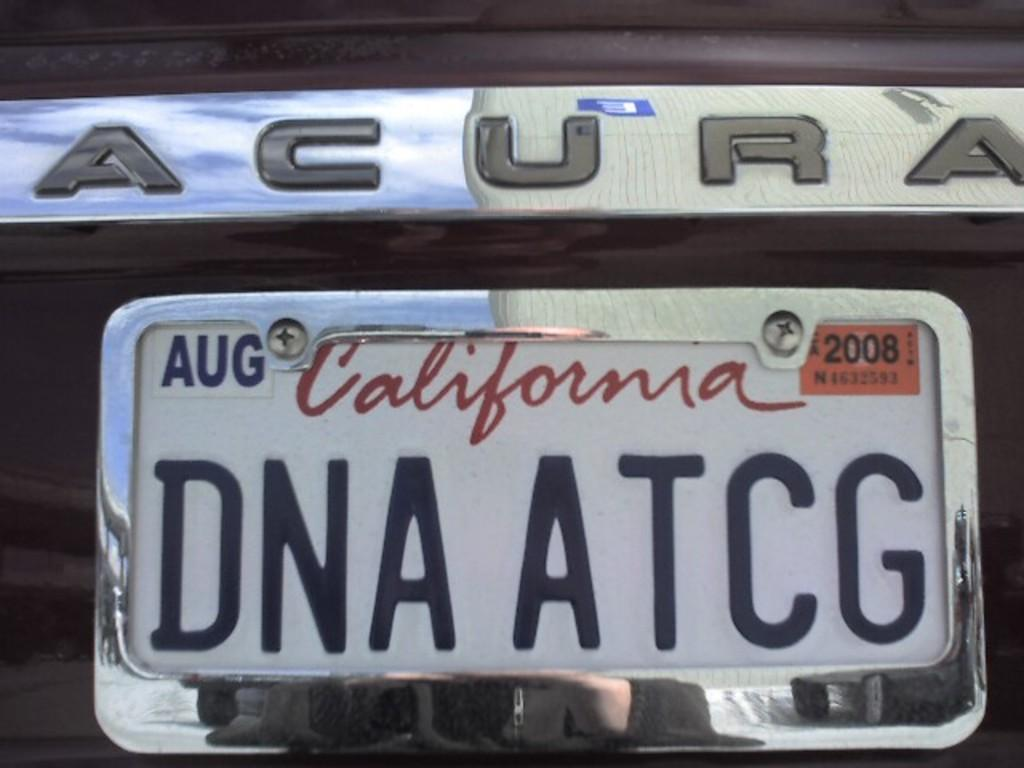What is the main subject of the image? The main subject of the image is a car. Can you describe any specific features of the car? Yes, the car has a number plate. How many goldfish are swimming in the car's engine in the image? There are no goldfish present in the image, and they cannot swim in a car's engine. What songs are being played by the car's stereo system in the image? There is no information about the car's stereo system or any songs being played in the image. 